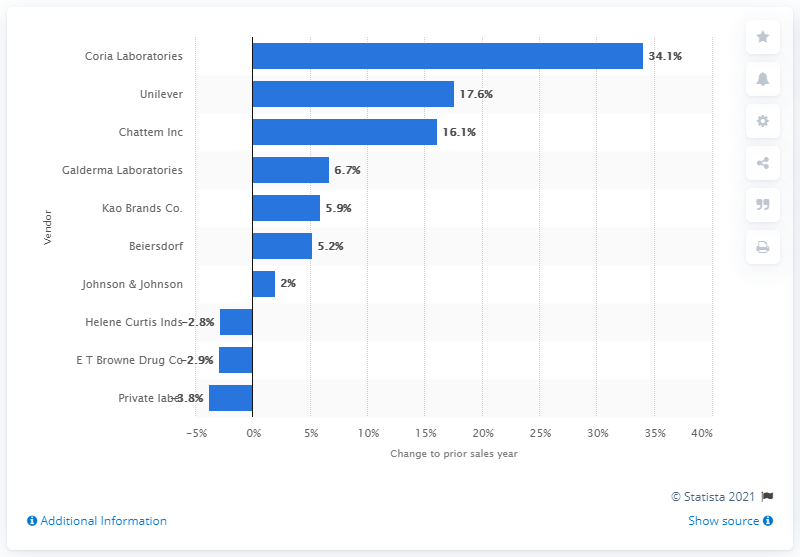Indicate a few pertinent items in this graphic. In 2013, Chattem Inc. had a sales growth of 16.1 percent in the hand and body lotion market. 